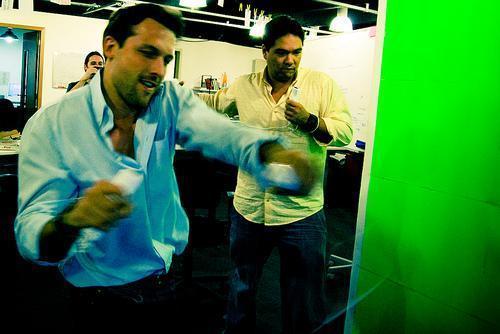How many people are in this picture?
Give a very brief answer. 3. How many people are playing the game?
Give a very brief answer. 2. 